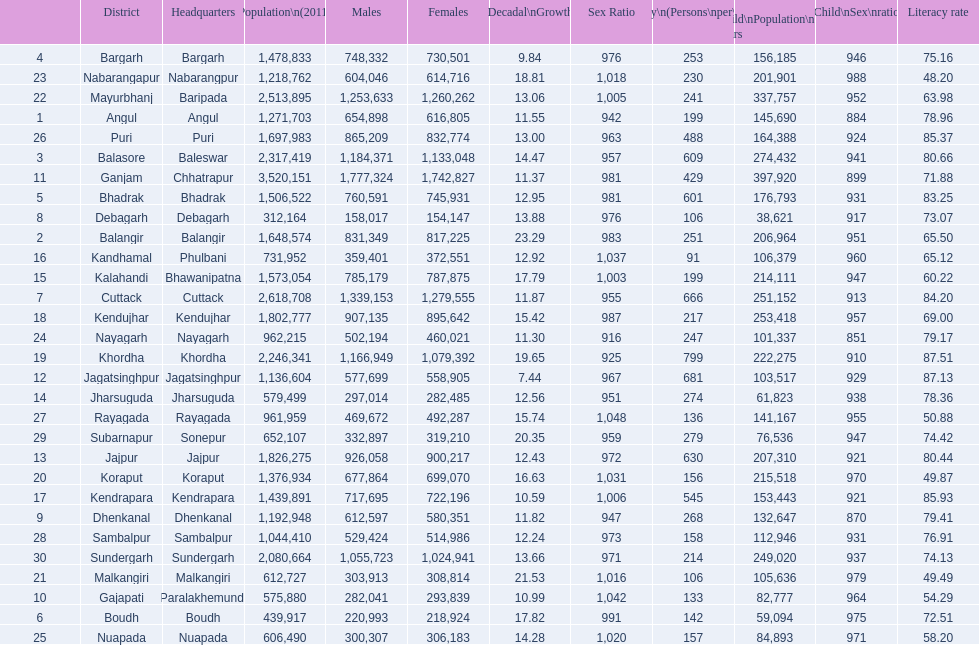Which district has a higher population, angul or cuttack? Cuttack. 